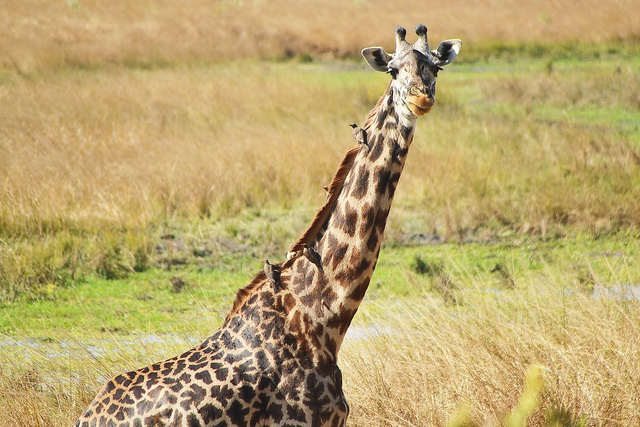Describe the objects in this image and their specific colors. I can see giraffe in tan, black, and gray tones, bird in tan, black, and gray tones, bird in tan and black tones, bird in tan, black, maroon, and gray tones, and bird in tan and maroon tones in this image. 